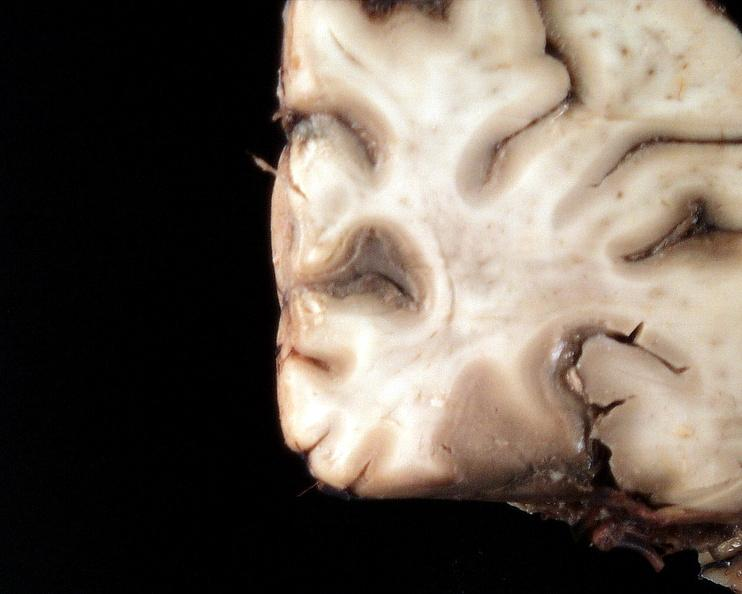s autoimmune thyroiditis present?
Answer the question using a single word or phrase. No 